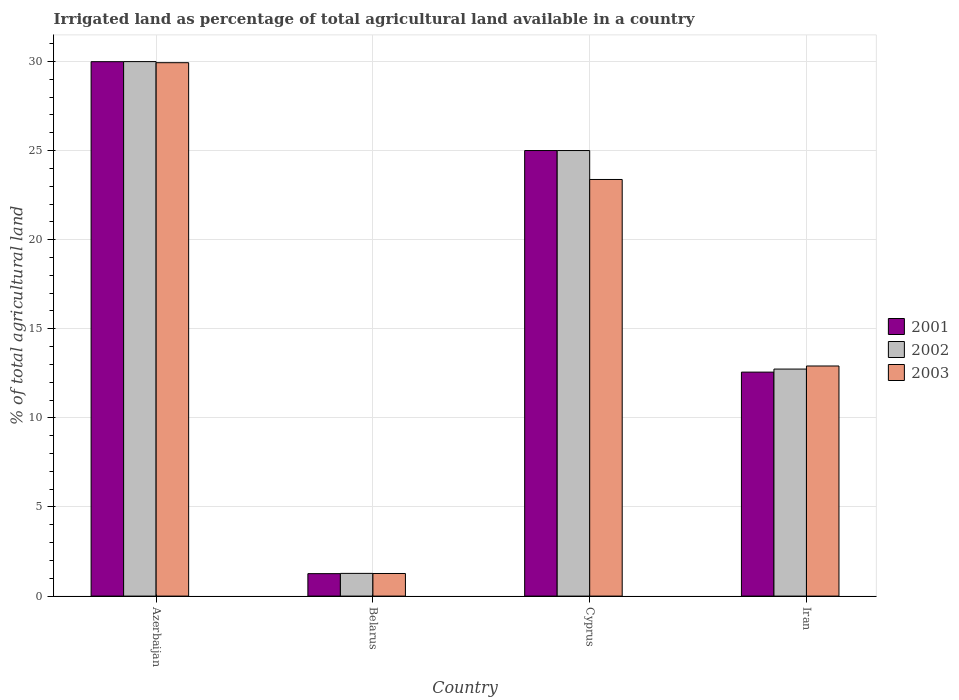Are the number of bars per tick equal to the number of legend labels?
Ensure brevity in your answer.  Yes. What is the label of the 3rd group of bars from the left?
Offer a very short reply. Cyprus. In how many cases, is the number of bars for a given country not equal to the number of legend labels?
Your answer should be very brief. 0. Across all countries, what is the maximum percentage of irrigated land in 2002?
Make the answer very short. 29.99. Across all countries, what is the minimum percentage of irrigated land in 2003?
Make the answer very short. 1.27. In which country was the percentage of irrigated land in 2001 maximum?
Make the answer very short. Azerbaijan. In which country was the percentage of irrigated land in 2001 minimum?
Provide a succinct answer. Belarus. What is the total percentage of irrigated land in 2003 in the graph?
Offer a terse response. 67.48. What is the difference between the percentage of irrigated land in 2001 in Azerbaijan and that in Iran?
Your response must be concise. 17.42. What is the difference between the percentage of irrigated land in 2003 in Belarus and the percentage of irrigated land in 2002 in Azerbaijan?
Your answer should be very brief. -28.72. What is the average percentage of irrigated land in 2002 per country?
Your answer should be very brief. 17.25. What is the difference between the percentage of irrigated land of/in 2001 and percentage of irrigated land of/in 2002 in Belarus?
Provide a short and direct response. -0.01. What is the ratio of the percentage of irrigated land in 2002 in Cyprus to that in Iran?
Offer a terse response. 1.96. Is the percentage of irrigated land in 2002 in Azerbaijan less than that in Iran?
Give a very brief answer. No. Is the difference between the percentage of irrigated land in 2001 in Belarus and Cyprus greater than the difference between the percentage of irrigated land in 2002 in Belarus and Cyprus?
Keep it short and to the point. No. What is the difference between the highest and the second highest percentage of irrigated land in 2002?
Ensure brevity in your answer.  12.26. What is the difference between the highest and the lowest percentage of irrigated land in 2001?
Keep it short and to the point. 28.73. In how many countries, is the percentage of irrigated land in 2001 greater than the average percentage of irrigated land in 2001 taken over all countries?
Your answer should be compact. 2. Is the sum of the percentage of irrigated land in 2003 in Azerbaijan and Iran greater than the maximum percentage of irrigated land in 2002 across all countries?
Offer a very short reply. Yes. What does the 3rd bar from the left in Belarus represents?
Your answer should be very brief. 2003. What does the 2nd bar from the right in Iran represents?
Give a very brief answer. 2002. Is it the case that in every country, the sum of the percentage of irrigated land in 2001 and percentage of irrigated land in 2002 is greater than the percentage of irrigated land in 2003?
Keep it short and to the point. Yes. How many bars are there?
Your answer should be compact. 12. Are all the bars in the graph horizontal?
Give a very brief answer. No. How many countries are there in the graph?
Your response must be concise. 4. What is the difference between two consecutive major ticks on the Y-axis?
Your answer should be compact. 5. Are the values on the major ticks of Y-axis written in scientific E-notation?
Provide a short and direct response. No. Does the graph contain grids?
Your response must be concise. Yes. What is the title of the graph?
Provide a succinct answer. Irrigated land as percentage of total agricultural land available in a country. What is the label or title of the Y-axis?
Provide a short and direct response. % of total agricultural land. What is the % of total agricultural land of 2001 in Azerbaijan?
Keep it short and to the point. 29.99. What is the % of total agricultural land in 2002 in Azerbaijan?
Make the answer very short. 29.99. What is the % of total agricultural land of 2003 in Azerbaijan?
Make the answer very short. 29.93. What is the % of total agricultural land of 2001 in Belarus?
Give a very brief answer. 1.26. What is the % of total agricultural land of 2002 in Belarus?
Offer a very short reply. 1.27. What is the % of total agricultural land in 2003 in Belarus?
Your answer should be compact. 1.27. What is the % of total agricultural land in 2002 in Cyprus?
Provide a short and direct response. 25. What is the % of total agricultural land of 2003 in Cyprus?
Provide a short and direct response. 23.38. What is the % of total agricultural land in 2001 in Iran?
Ensure brevity in your answer.  12.57. What is the % of total agricultural land in 2002 in Iran?
Make the answer very short. 12.74. What is the % of total agricultural land of 2003 in Iran?
Your response must be concise. 12.91. Across all countries, what is the maximum % of total agricultural land of 2001?
Make the answer very short. 29.99. Across all countries, what is the maximum % of total agricultural land in 2002?
Offer a terse response. 29.99. Across all countries, what is the maximum % of total agricultural land in 2003?
Provide a succinct answer. 29.93. Across all countries, what is the minimum % of total agricultural land in 2001?
Provide a short and direct response. 1.26. Across all countries, what is the minimum % of total agricultural land in 2002?
Offer a terse response. 1.27. Across all countries, what is the minimum % of total agricultural land of 2003?
Your response must be concise. 1.27. What is the total % of total agricultural land in 2001 in the graph?
Make the answer very short. 68.81. What is the total % of total agricultural land of 2002 in the graph?
Provide a short and direct response. 69. What is the total % of total agricultural land in 2003 in the graph?
Ensure brevity in your answer.  67.48. What is the difference between the % of total agricultural land in 2001 in Azerbaijan and that in Belarus?
Your answer should be compact. 28.73. What is the difference between the % of total agricultural land of 2002 in Azerbaijan and that in Belarus?
Offer a terse response. 28.72. What is the difference between the % of total agricultural land in 2003 in Azerbaijan and that in Belarus?
Your answer should be compact. 28.66. What is the difference between the % of total agricultural land in 2001 in Azerbaijan and that in Cyprus?
Offer a terse response. 4.99. What is the difference between the % of total agricultural land in 2002 in Azerbaijan and that in Cyprus?
Your response must be concise. 4.99. What is the difference between the % of total agricultural land of 2003 in Azerbaijan and that in Cyprus?
Offer a very short reply. 6.55. What is the difference between the % of total agricultural land in 2001 in Azerbaijan and that in Iran?
Offer a very short reply. 17.42. What is the difference between the % of total agricultural land in 2002 in Azerbaijan and that in Iran?
Your answer should be compact. 17.25. What is the difference between the % of total agricultural land in 2003 in Azerbaijan and that in Iran?
Provide a succinct answer. 17.02. What is the difference between the % of total agricultural land of 2001 in Belarus and that in Cyprus?
Provide a succinct answer. -23.74. What is the difference between the % of total agricultural land of 2002 in Belarus and that in Cyprus?
Ensure brevity in your answer.  -23.73. What is the difference between the % of total agricultural land of 2003 in Belarus and that in Cyprus?
Your answer should be compact. -22.11. What is the difference between the % of total agricultural land in 2001 in Belarus and that in Iran?
Provide a short and direct response. -11.31. What is the difference between the % of total agricultural land of 2002 in Belarus and that in Iran?
Offer a very short reply. -11.46. What is the difference between the % of total agricultural land in 2003 in Belarus and that in Iran?
Ensure brevity in your answer.  -11.64. What is the difference between the % of total agricultural land in 2001 in Cyprus and that in Iran?
Offer a terse response. 12.43. What is the difference between the % of total agricultural land in 2002 in Cyprus and that in Iran?
Your response must be concise. 12.26. What is the difference between the % of total agricultural land of 2003 in Cyprus and that in Iran?
Make the answer very short. 10.47. What is the difference between the % of total agricultural land of 2001 in Azerbaijan and the % of total agricultural land of 2002 in Belarus?
Make the answer very short. 28.71. What is the difference between the % of total agricultural land of 2001 in Azerbaijan and the % of total agricultural land of 2003 in Belarus?
Provide a short and direct response. 28.72. What is the difference between the % of total agricultural land in 2002 in Azerbaijan and the % of total agricultural land in 2003 in Belarus?
Ensure brevity in your answer.  28.72. What is the difference between the % of total agricultural land in 2001 in Azerbaijan and the % of total agricultural land in 2002 in Cyprus?
Your answer should be very brief. 4.99. What is the difference between the % of total agricultural land in 2001 in Azerbaijan and the % of total agricultural land in 2003 in Cyprus?
Your answer should be very brief. 6.61. What is the difference between the % of total agricultural land in 2002 in Azerbaijan and the % of total agricultural land in 2003 in Cyprus?
Provide a short and direct response. 6.61. What is the difference between the % of total agricultural land of 2001 in Azerbaijan and the % of total agricultural land of 2002 in Iran?
Offer a very short reply. 17.25. What is the difference between the % of total agricultural land in 2001 in Azerbaijan and the % of total agricultural land in 2003 in Iran?
Make the answer very short. 17.08. What is the difference between the % of total agricultural land in 2002 in Azerbaijan and the % of total agricultural land in 2003 in Iran?
Your answer should be very brief. 17.08. What is the difference between the % of total agricultural land in 2001 in Belarus and the % of total agricultural land in 2002 in Cyprus?
Keep it short and to the point. -23.74. What is the difference between the % of total agricultural land in 2001 in Belarus and the % of total agricultural land in 2003 in Cyprus?
Your answer should be compact. -22.12. What is the difference between the % of total agricultural land of 2002 in Belarus and the % of total agricultural land of 2003 in Cyprus?
Your answer should be compact. -22.1. What is the difference between the % of total agricultural land of 2001 in Belarus and the % of total agricultural land of 2002 in Iran?
Ensure brevity in your answer.  -11.48. What is the difference between the % of total agricultural land in 2001 in Belarus and the % of total agricultural land in 2003 in Iran?
Ensure brevity in your answer.  -11.65. What is the difference between the % of total agricultural land of 2002 in Belarus and the % of total agricultural land of 2003 in Iran?
Provide a short and direct response. -11.64. What is the difference between the % of total agricultural land of 2001 in Cyprus and the % of total agricultural land of 2002 in Iran?
Keep it short and to the point. 12.26. What is the difference between the % of total agricultural land of 2001 in Cyprus and the % of total agricultural land of 2003 in Iran?
Offer a terse response. 12.09. What is the difference between the % of total agricultural land of 2002 in Cyprus and the % of total agricultural land of 2003 in Iran?
Make the answer very short. 12.09. What is the average % of total agricultural land of 2001 per country?
Provide a succinct answer. 17.2. What is the average % of total agricultural land of 2002 per country?
Give a very brief answer. 17.25. What is the average % of total agricultural land in 2003 per country?
Your response must be concise. 16.87. What is the difference between the % of total agricultural land of 2001 and % of total agricultural land of 2002 in Azerbaijan?
Provide a short and direct response. -0. What is the difference between the % of total agricultural land in 2001 and % of total agricultural land in 2003 in Azerbaijan?
Provide a succinct answer. 0.06. What is the difference between the % of total agricultural land of 2002 and % of total agricultural land of 2003 in Azerbaijan?
Provide a short and direct response. 0.06. What is the difference between the % of total agricultural land in 2001 and % of total agricultural land in 2002 in Belarus?
Keep it short and to the point. -0.01. What is the difference between the % of total agricultural land of 2001 and % of total agricultural land of 2003 in Belarus?
Provide a short and direct response. -0.01. What is the difference between the % of total agricultural land in 2002 and % of total agricultural land in 2003 in Belarus?
Provide a short and direct response. 0.01. What is the difference between the % of total agricultural land in 2001 and % of total agricultural land in 2002 in Cyprus?
Offer a terse response. 0. What is the difference between the % of total agricultural land in 2001 and % of total agricultural land in 2003 in Cyprus?
Provide a succinct answer. 1.62. What is the difference between the % of total agricultural land of 2002 and % of total agricultural land of 2003 in Cyprus?
Offer a very short reply. 1.62. What is the difference between the % of total agricultural land of 2001 and % of total agricultural land of 2002 in Iran?
Offer a very short reply. -0.17. What is the difference between the % of total agricultural land in 2001 and % of total agricultural land in 2003 in Iran?
Ensure brevity in your answer.  -0.34. What is the difference between the % of total agricultural land of 2002 and % of total agricultural land of 2003 in Iran?
Ensure brevity in your answer.  -0.17. What is the ratio of the % of total agricultural land of 2001 in Azerbaijan to that in Belarus?
Your response must be concise. 23.8. What is the ratio of the % of total agricultural land in 2002 in Azerbaijan to that in Belarus?
Offer a very short reply. 23.54. What is the ratio of the % of total agricultural land in 2003 in Azerbaijan to that in Belarus?
Make the answer very short. 23.59. What is the ratio of the % of total agricultural land of 2001 in Azerbaijan to that in Cyprus?
Your response must be concise. 1.2. What is the ratio of the % of total agricultural land in 2002 in Azerbaijan to that in Cyprus?
Provide a short and direct response. 1.2. What is the ratio of the % of total agricultural land of 2003 in Azerbaijan to that in Cyprus?
Provide a succinct answer. 1.28. What is the ratio of the % of total agricultural land of 2001 in Azerbaijan to that in Iran?
Your answer should be compact. 2.39. What is the ratio of the % of total agricultural land of 2002 in Azerbaijan to that in Iran?
Offer a very short reply. 2.35. What is the ratio of the % of total agricultural land in 2003 in Azerbaijan to that in Iran?
Your response must be concise. 2.32. What is the ratio of the % of total agricultural land of 2001 in Belarus to that in Cyprus?
Your answer should be compact. 0.05. What is the ratio of the % of total agricultural land of 2002 in Belarus to that in Cyprus?
Ensure brevity in your answer.  0.05. What is the ratio of the % of total agricultural land of 2003 in Belarus to that in Cyprus?
Give a very brief answer. 0.05. What is the ratio of the % of total agricultural land in 2001 in Belarus to that in Iran?
Ensure brevity in your answer.  0.1. What is the ratio of the % of total agricultural land of 2003 in Belarus to that in Iran?
Ensure brevity in your answer.  0.1. What is the ratio of the % of total agricultural land of 2001 in Cyprus to that in Iran?
Give a very brief answer. 1.99. What is the ratio of the % of total agricultural land in 2002 in Cyprus to that in Iran?
Offer a very short reply. 1.96. What is the ratio of the % of total agricultural land of 2003 in Cyprus to that in Iran?
Ensure brevity in your answer.  1.81. What is the difference between the highest and the second highest % of total agricultural land in 2001?
Offer a very short reply. 4.99. What is the difference between the highest and the second highest % of total agricultural land of 2002?
Give a very brief answer. 4.99. What is the difference between the highest and the second highest % of total agricultural land in 2003?
Offer a very short reply. 6.55. What is the difference between the highest and the lowest % of total agricultural land in 2001?
Your answer should be compact. 28.73. What is the difference between the highest and the lowest % of total agricultural land in 2002?
Your response must be concise. 28.72. What is the difference between the highest and the lowest % of total agricultural land in 2003?
Make the answer very short. 28.66. 